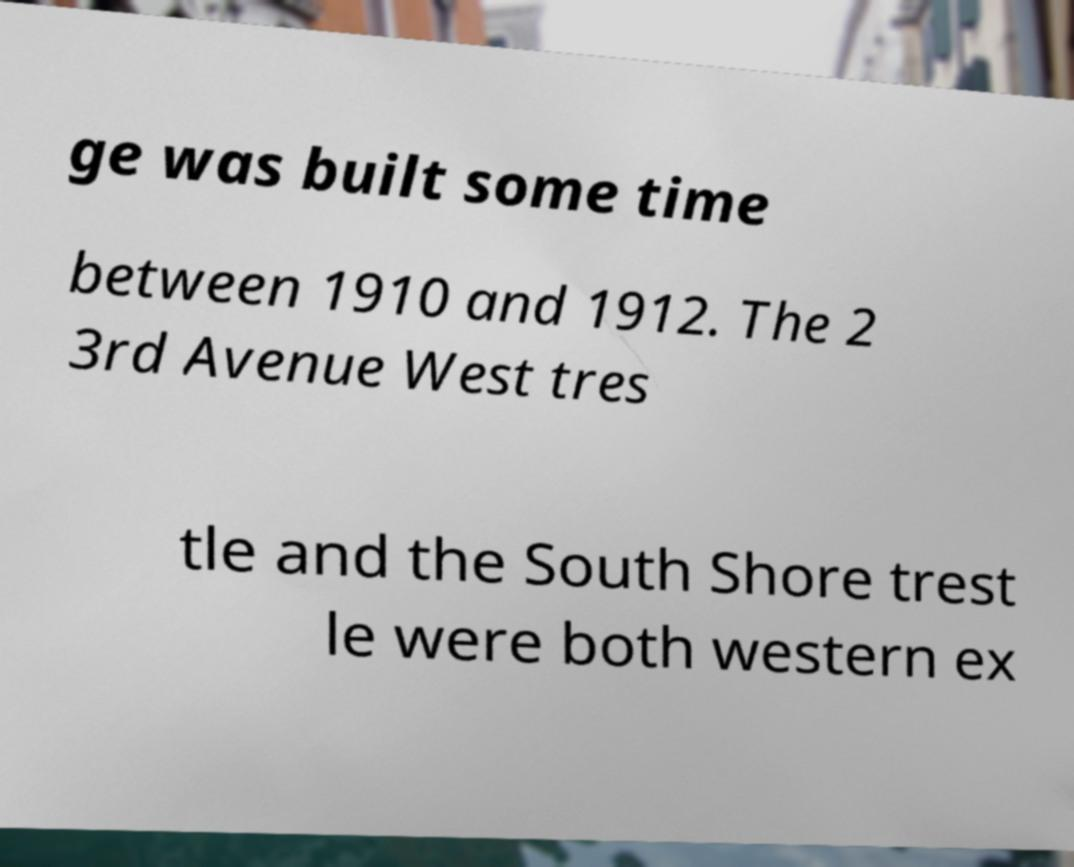Please identify and transcribe the text found in this image. ge was built some time between 1910 and 1912. The 2 3rd Avenue West tres tle and the South Shore trest le were both western ex 